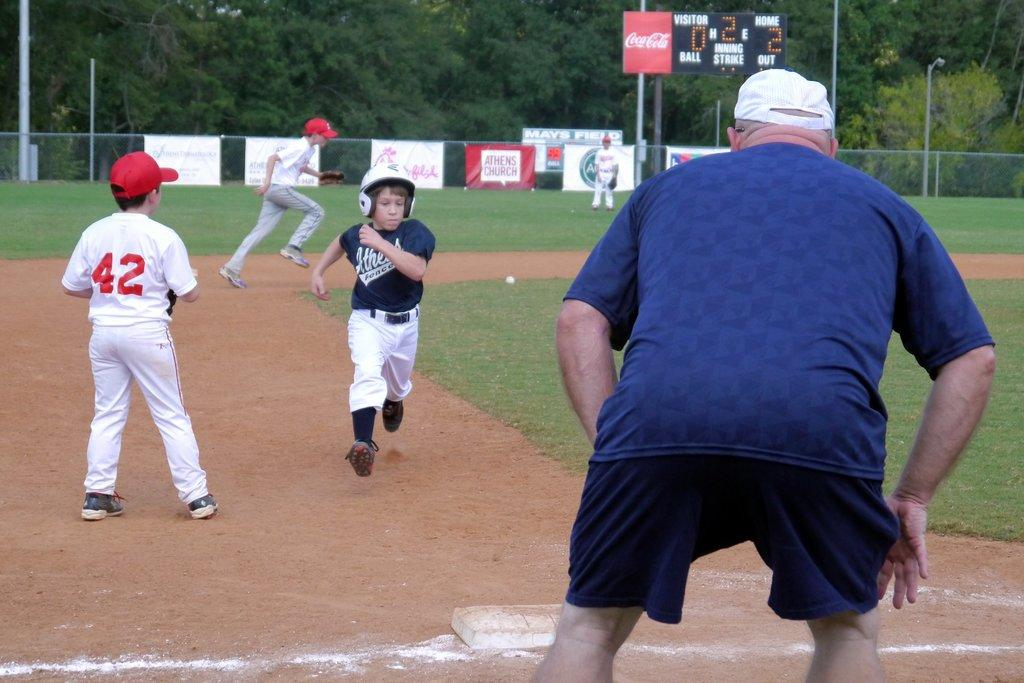<image>
Summarize the visual content of the image. A boy with the number 42 on the back of his jersey is playing a game of baseball. 